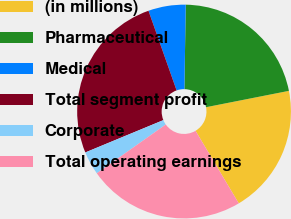<chart> <loc_0><loc_0><loc_500><loc_500><pie_chart><fcel>(in millions)<fcel>Pharmaceutical<fcel>Medical<fcel>Total segment profit<fcel>Corporate<fcel>Total operating earnings<nl><fcel>19.55%<fcel>21.65%<fcel>5.65%<fcel>25.85%<fcel>3.55%<fcel>23.75%<nl></chart> 